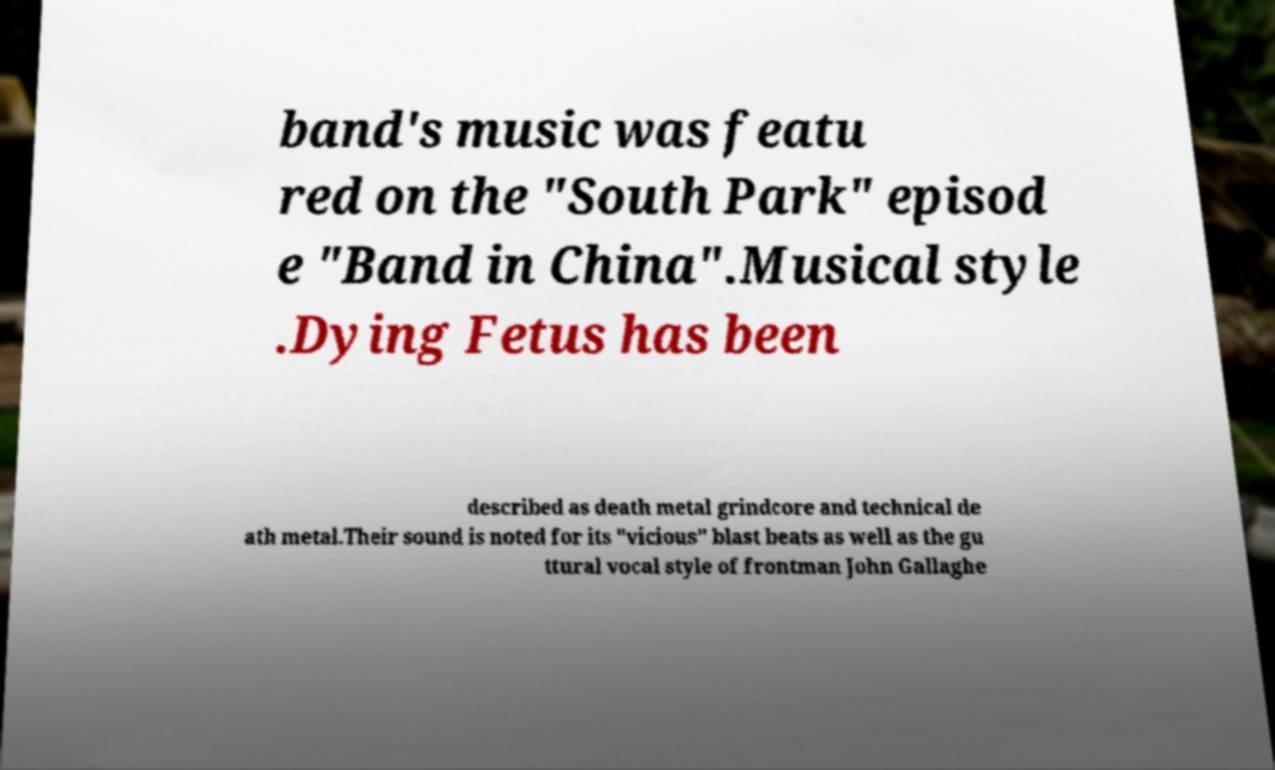Please identify and transcribe the text found in this image. band's music was featu red on the "South Park" episod e "Band in China".Musical style .Dying Fetus has been described as death metal grindcore and technical de ath metal.Their sound is noted for its "vicious" blast beats as well as the gu ttural vocal style of frontman John Gallaghe 